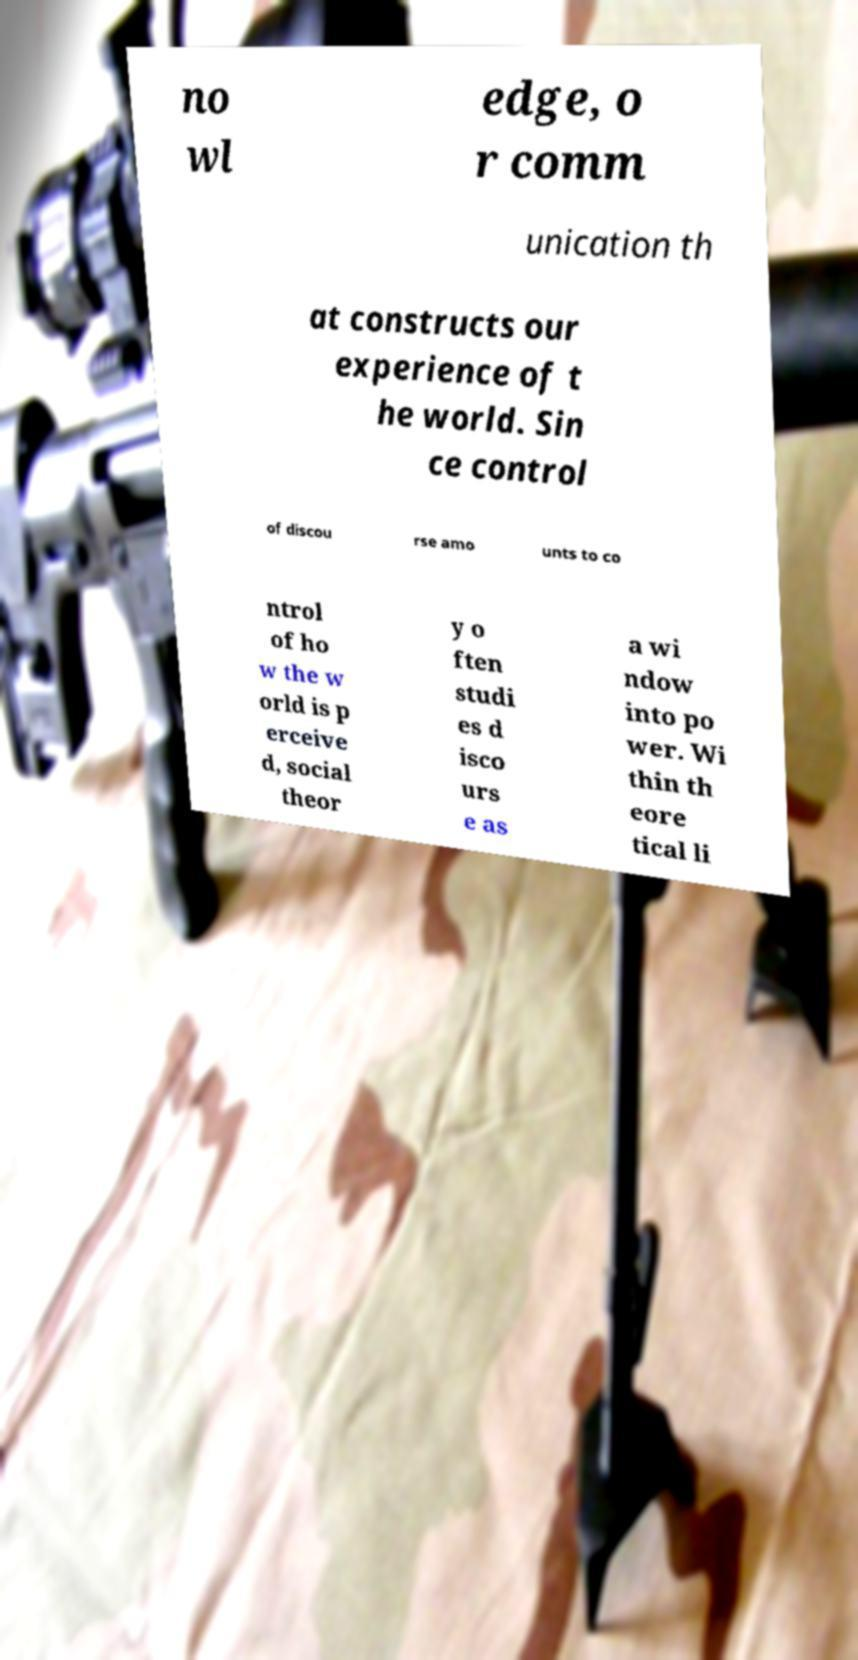I need the written content from this picture converted into text. Can you do that? no wl edge, o r comm unication th at constructs our experience of t he world. Sin ce control of discou rse amo unts to co ntrol of ho w the w orld is p erceive d, social theor y o ften studi es d isco urs e as a wi ndow into po wer. Wi thin th eore tical li 